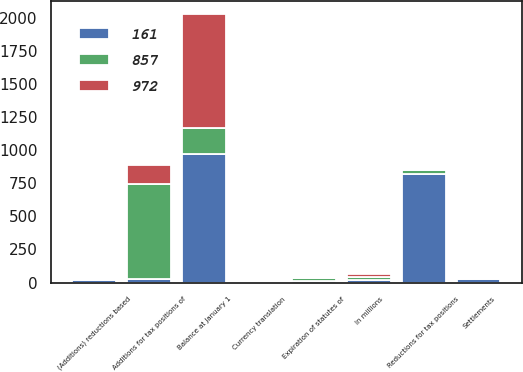Convert chart to OTSL. <chart><loc_0><loc_0><loc_500><loc_500><stacked_bar_chart><ecel><fcel>In millions<fcel>Balance at January 1<fcel>(Additions) reductions based<fcel>Additions for tax positions of<fcel>Reductions for tax positions<fcel>Settlements<fcel>Expiration of statutes of<fcel>Currency translation<nl><fcel>161<fcel>22<fcel>972<fcel>22<fcel>29<fcel>824<fcel>26<fcel>11<fcel>1<nl><fcel>972<fcel>22<fcel>857<fcel>12<fcel>140<fcel>6<fcel>2<fcel>7<fcel>2<nl><fcel>857<fcel>22<fcel>199<fcel>2<fcel>719<fcel>29<fcel>2<fcel>25<fcel>7<nl></chart> 